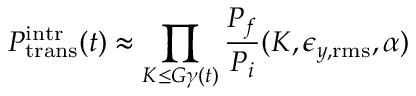<formula> <loc_0><loc_0><loc_500><loc_500>P _ { t r a n s } ^ { i n t r } ( t ) \approx \prod _ { K \leq G \gamma ( t ) } \frac { P _ { f } } { P _ { i } } ( K , \epsilon _ { y , r m s } , \alpha )</formula> 